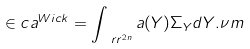Convert formula to latex. <formula><loc_0><loc_0><loc_500><loc_500>\in c a ^ { W i c k } = \int _ { \ r r ^ { 2 n } } { a ( Y ) \Sigma _ { Y } d Y } . \nu m</formula> 